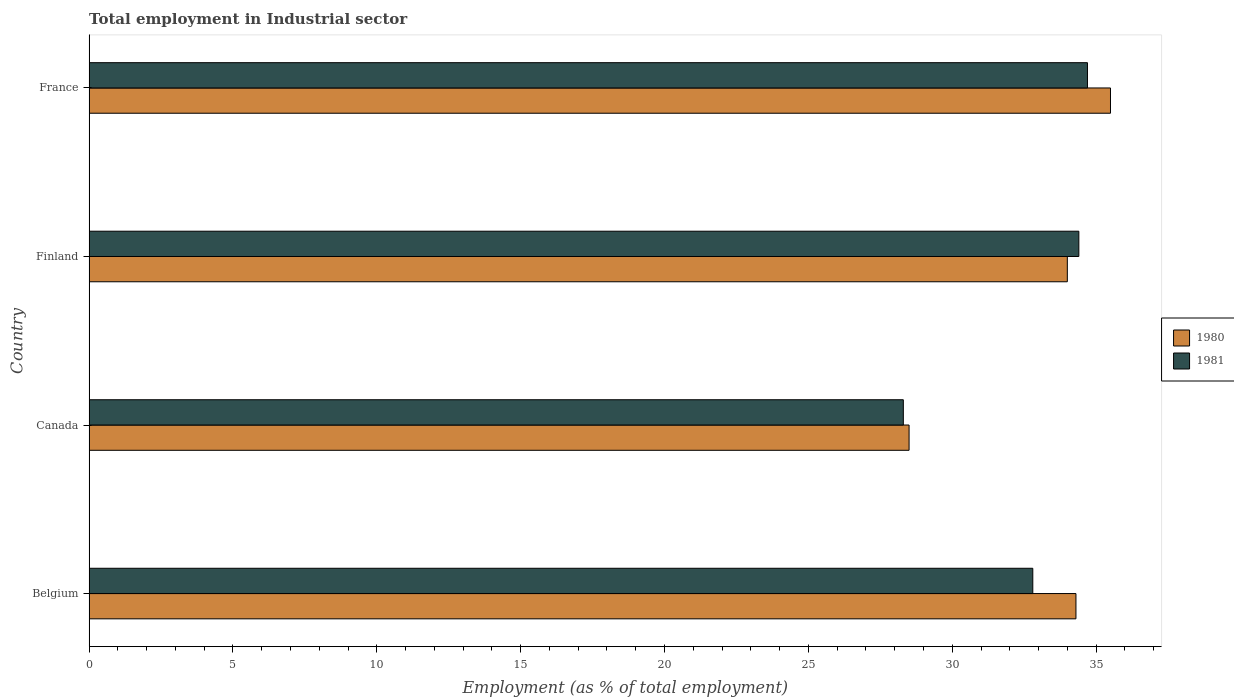How many different coloured bars are there?
Your answer should be compact. 2. How many bars are there on the 4th tick from the bottom?
Provide a short and direct response. 2. What is the label of the 3rd group of bars from the top?
Make the answer very short. Canada. What is the employment in industrial sector in 1980 in Canada?
Offer a very short reply. 28.5. Across all countries, what is the maximum employment in industrial sector in 1981?
Your answer should be very brief. 34.7. In which country was the employment in industrial sector in 1981 maximum?
Provide a succinct answer. France. In which country was the employment in industrial sector in 1980 minimum?
Ensure brevity in your answer.  Canada. What is the total employment in industrial sector in 1981 in the graph?
Provide a succinct answer. 130.2. What is the difference between the employment in industrial sector in 1981 in Canada and that in Finland?
Your answer should be very brief. -6.1. What is the difference between the employment in industrial sector in 1981 in Finland and the employment in industrial sector in 1980 in Belgium?
Make the answer very short. 0.1. What is the average employment in industrial sector in 1981 per country?
Offer a very short reply. 32.55. What is the difference between the employment in industrial sector in 1980 and employment in industrial sector in 1981 in France?
Your response must be concise. 0.8. What is the ratio of the employment in industrial sector in 1980 in Canada to that in France?
Your response must be concise. 0.8. Is the employment in industrial sector in 1980 in Canada less than that in Finland?
Your answer should be very brief. Yes. What is the difference between the highest and the second highest employment in industrial sector in 1981?
Provide a short and direct response. 0.3. What is the difference between the highest and the lowest employment in industrial sector in 1981?
Make the answer very short. 6.4. In how many countries, is the employment in industrial sector in 1980 greater than the average employment in industrial sector in 1980 taken over all countries?
Your answer should be very brief. 3. Is the sum of the employment in industrial sector in 1981 in Belgium and Finland greater than the maximum employment in industrial sector in 1980 across all countries?
Offer a terse response. Yes. What does the 1st bar from the top in France represents?
Keep it short and to the point. 1981. What does the 1st bar from the bottom in Belgium represents?
Provide a succinct answer. 1980. How many bars are there?
Your response must be concise. 8. Are all the bars in the graph horizontal?
Your answer should be very brief. Yes. Does the graph contain any zero values?
Make the answer very short. No. Does the graph contain grids?
Provide a short and direct response. No. Where does the legend appear in the graph?
Give a very brief answer. Center right. How are the legend labels stacked?
Offer a terse response. Vertical. What is the title of the graph?
Provide a short and direct response. Total employment in Industrial sector. Does "1995" appear as one of the legend labels in the graph?
Provide a succinct answer. No. What is the label or title of the X-axis?
Your answer should be compact. Employment (as % of total employment). What is the label or title of the Y-axis?
Your response must be concise. Country. What is the Employment (as % of total employment) in 1980 in Belgium?
Provide a succinct answer. 34.3. What is the Employment (as % of total employment) in 1981 in Belgium?
Provide a succinct answer. 32.8. What is the Employment (as % of total employment) of 1980 in Canada?
Offer a very short reply. 28.5. What is the Employment (as % of total employment) of 1981 in Canada?
Your answer should be very brief. 28.3. What is the Employment (as % of total employment) of 1981 in Finland?
Your response must be concise. 34.4. What is the Employment (as % of total employment) in 1980 in France?
Give a very brief answer. 35.5. What is the Employment (as % of total employment) in 1981 in France?
Your answer should be compact. 34.7. Across all countries, what is the maximum Employment (as % of total employment) of 1980?
Give a very brief answer. 35.5. Across all countries, what is the maximum Employment (as % of total employment) of 1981?
Provide a short and direct response. 34.7. Across all countries, what is the minimum Employment (as % of total employment) of 1980?
Your answer should be very brief. 28.5. Across all countries, what is the minimum Employment (as % of total employment) in 1981?
Give a very brief answer. 28.3. What is the total Employment (as % of total employment) in 1980 in the graph?
Offer a terse response. 132.3. What is the total Employment (as % of total employment) in 1981 in the graph?
Offer a terse response. 130.2. What is the difference between the Employment (as % of total employment) of 1980 in Belgium and that in Canada?
Make the answer very short. 5.8. What is the difference between the Employment (as % of total employment) of 1980 in Belgium and that in Finland?
Provide a short and direct response. 0.3. What is the difference between the Employment (as % of total employment) in 1981 in Belgium and that in Finland?
Ensure brevity in your answer.  -1.6. What is the difference between the Employment (as % of total employment) in 1980 in Finland and that in France?
Ensure brevity in your answer.  -1.5. What is the difference between the Employment (as % of total employment) in 1980 in Belgium and the Employment (as % of total employment) in 1981 in Canada?
Offer a terse response. 6. What is the difference between the Employment (as % of total employment) in 1980 in Canada and the Employment (as % of total employment) in 1981 in France?
Your response must be concise. -6.2. What is the difference between the Employment (as % of total employment) in 1980 in Finland and the Employment (as % of total employment) in 1981 in France?
Give a very brief answer. -0.7. What is the average Employment (as % of total employment) in 1980 per country?
Provide a short and direct response. 33.08. What is the average Employment (as % of total employment) in 1981 per country?
Make the answer very short. 32.55. What is the difference between the Employment (as % of total employment) in 1980 and Employment (as % of total employment) in 1981 in Canada?
Keep it short and to the point. 0.2. What is the ratio of the Employment (as % of total employment) in 1980 in Belgium to that in Canada?
Your response must be concise. 1.2. What is the ratio of the Employment (as % of total employment) in 1981 in Belgium to that in Canada?
Ensure brevity in your answer.  1.16. What is the ratio of the Employment (as % of total employment) in 1980 in Belgium to that in Finland?
Provide a succinct answer. 1.01. What is the ratio of the Employment (as % of total employment) of 1981 in Belgium to that in Finland?
Offer a very short reply. 0.95. What is the ratio of the Employment (as % of total employment) of 1980 in Belgium to that in France?
Ensure brevity in your answer.  0.97. What is the ratio of the Employment (as % of total employment) of 1981 in Belgium to that in France?
Give a very brief answer. 0.95. What is the ratio of the Employment (as % of total employment) in 1980 in Canada to that in Finland?
Your answer should be very brief. 0.84. What is the ratio of the Employment (as % of total employment) in 1981 in Canada to that in Finland?
Your response must be concise. 0.82. What is the ratio of the Employment (as % of total employment) in 1980 in Canada to that in France?
Your answer should be compact. 0.8. What is the ratio of the Employment (as % of total employment) of 1981 in Canada to that in France?
Keep it short and to the point. 0.82. What is the ratio of the Employment (as % of total employment) in 1980 in Finland to that in France?
Your answer should be very brief. 0.96. What is the difference between the highest and the second highest Employment (as % of total employment) of 1980?
Your response must be concise. 1.2. What is the difference between the highest and the lowest Employment (as % of total employment) in 1981?
Provide a short and direct response. 6.4. 